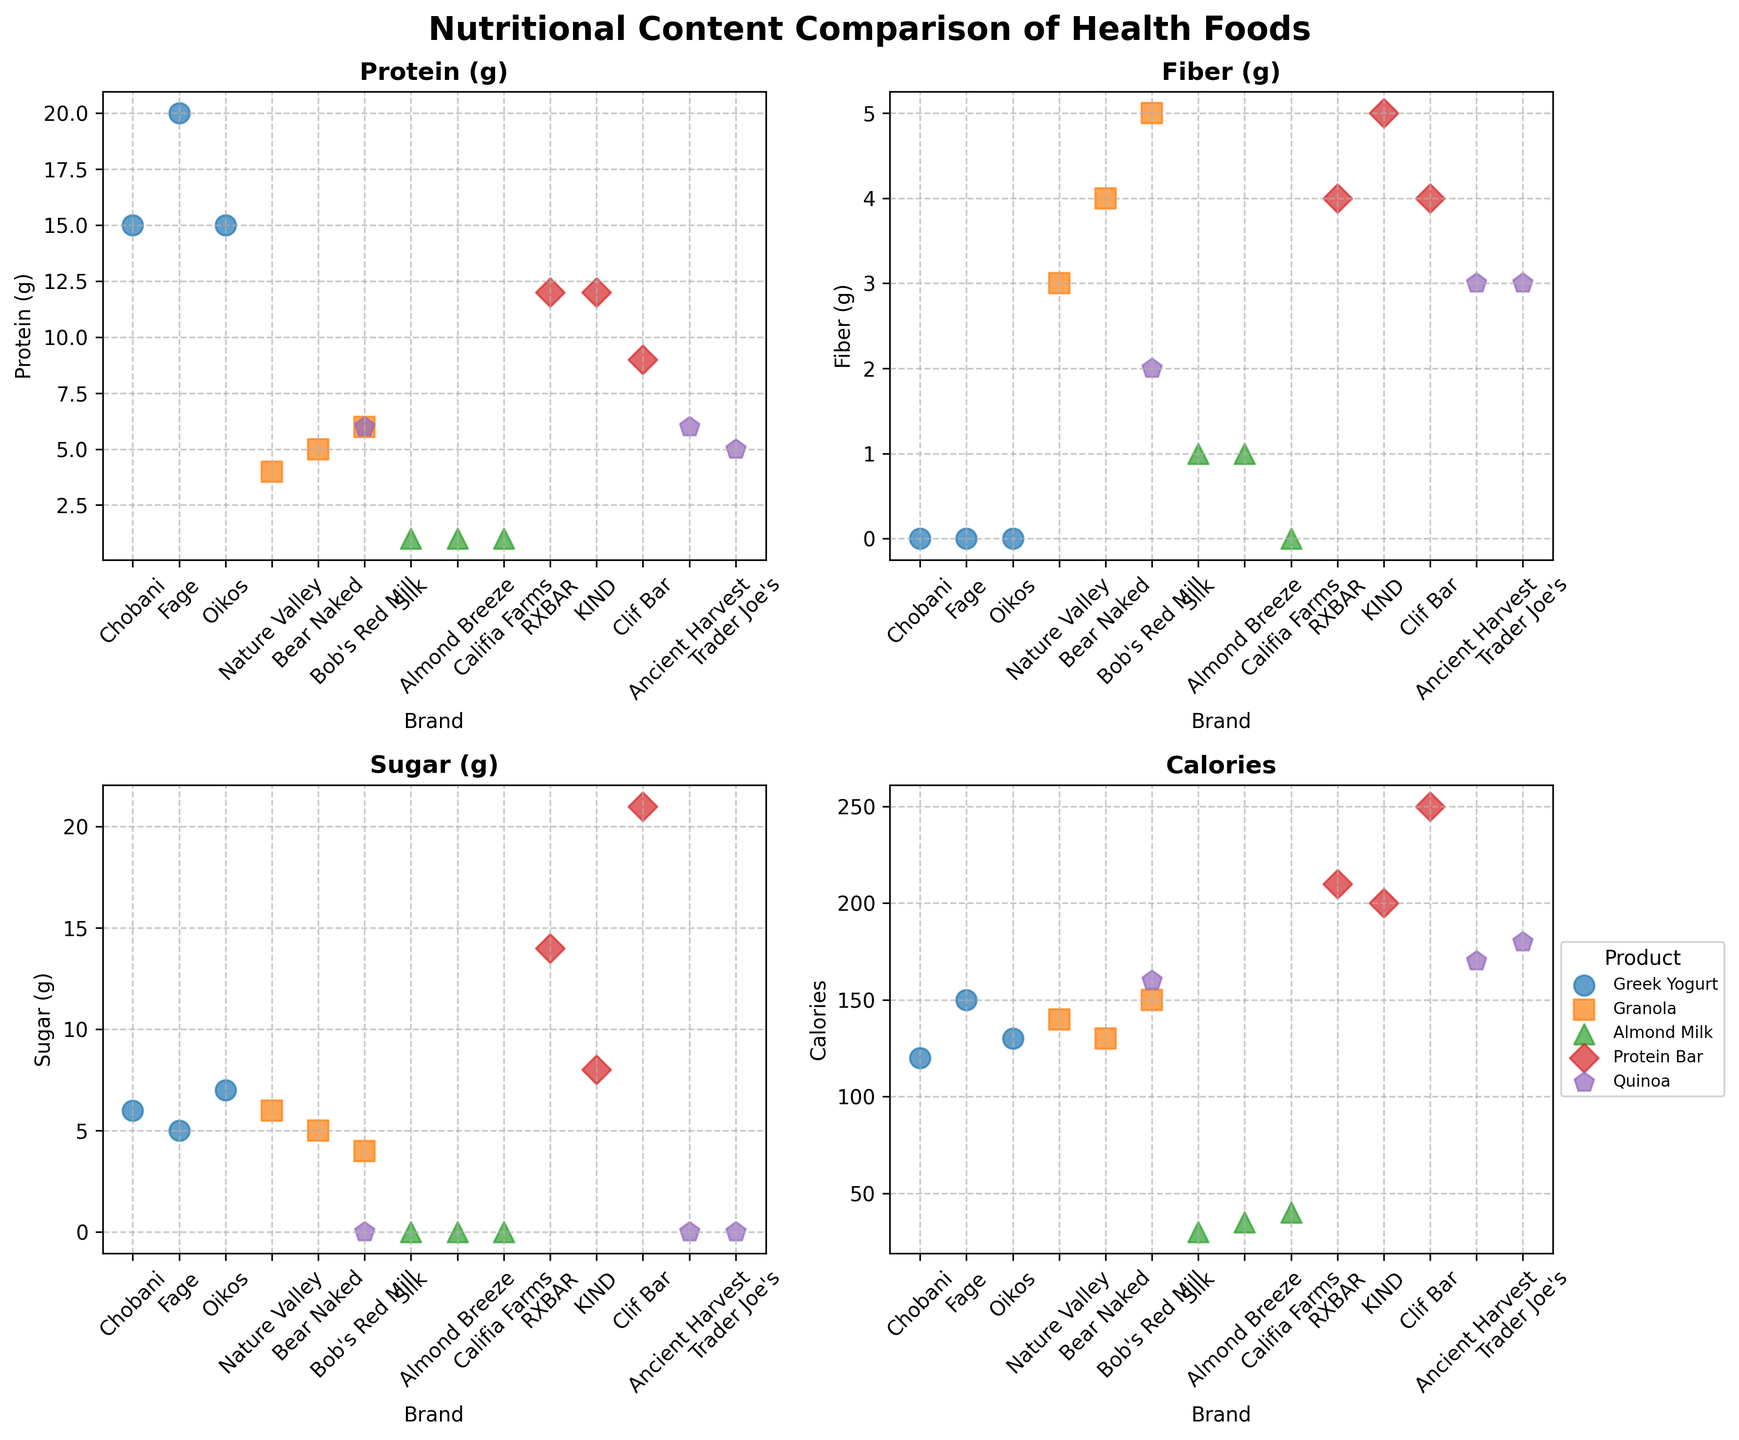How many different products are compared in the figure? By counting the unique products mentioned in the legend, we can see that the different products being compared are Greek Yogurt, Granola, Almond Milk, Protein Bar, and Quinoa. This makes a total of 5 products.
Answer: 5 Which product has the highest fiber content? To find the product with the highest fiber content, we look at the subplot titled "Fiber (g)" and identify the highest value on the y-axis, which corresponds to the product "Protein Bar" (KIND with 5g).
Answer: Protein Bar What is the average sugar content for Protein Bars? To find the average sugar content for Protein Bars, we find the sugar content for RXBAR, KIND, and Clif Bar which are 14g, 8g, and 21g respectively. Summing these up gives 14 + 8 + 21 = 43. Dividing by the number of data points (3) gives an average sugar content of 43/3 ≈ 14.33g.
Answer: 14.33g Between Chobani and Fage Greek Yogurt, which brand has fewer calories? By checking the "Calories" subplot, we observe that Chobani has 120 calories, while Fage has 150 calories. Therefore, Chobani has fewer calories.
Answer: Chobani Which brand of Almond Milk has the least calories? Inspecting the "Calories" subplot for Almond Milk, Silk has the least calories with 30, compared to Almond Breeze with 35, and Califia Farms with 40.
Answer: Silk In terms of protein content, which product has the highest variability across different brands? By evaluating the "Protein (g)" subplot and considering the spread of values for each product, Protein Bars show the highest variability. RXBAR has 12g, KIND has 12g, and Clif Bar has 9g, creating a wider spread in comparison to other products.
Answer: Protein Bars Which product, on average, has the lowest sugar content across different brands? Calculating the average sugar content for each product from their respective brands:
- Greek Yogurt: (6 + 5 + 7)/3 = 6
- Granola: (6 + 5 + 4)/3 ≈ 5
- Almond Milk: (0 + 0 + 0)/3 = 0
- Protein Bar: (14 + 8 + 21)/3 ≈ 14.33
- Quinoa: (0 + 0 + 0)/3 = 0
Both Almond Milk and Quinoa have an average sugar content of 0.
Answer: Almond Milk and Quinoa Which brand of Granola has the highest fiber content? Checking the "Fiber (g)" subplot, Bob's Red Mill has the highest fiber content with 5g among Nature Valley (3g) and Bear Naked (4g).
Answer: Bob's Red Mill Which product has the most consistent fiber content across its brands? Examining the "Fiber (g)" subplot, Greek Yogurt has the most consistent fiber content as it remains at 0g for all brands (Chobani, Fage, Oikos).
Answer: Greek Yogurt 